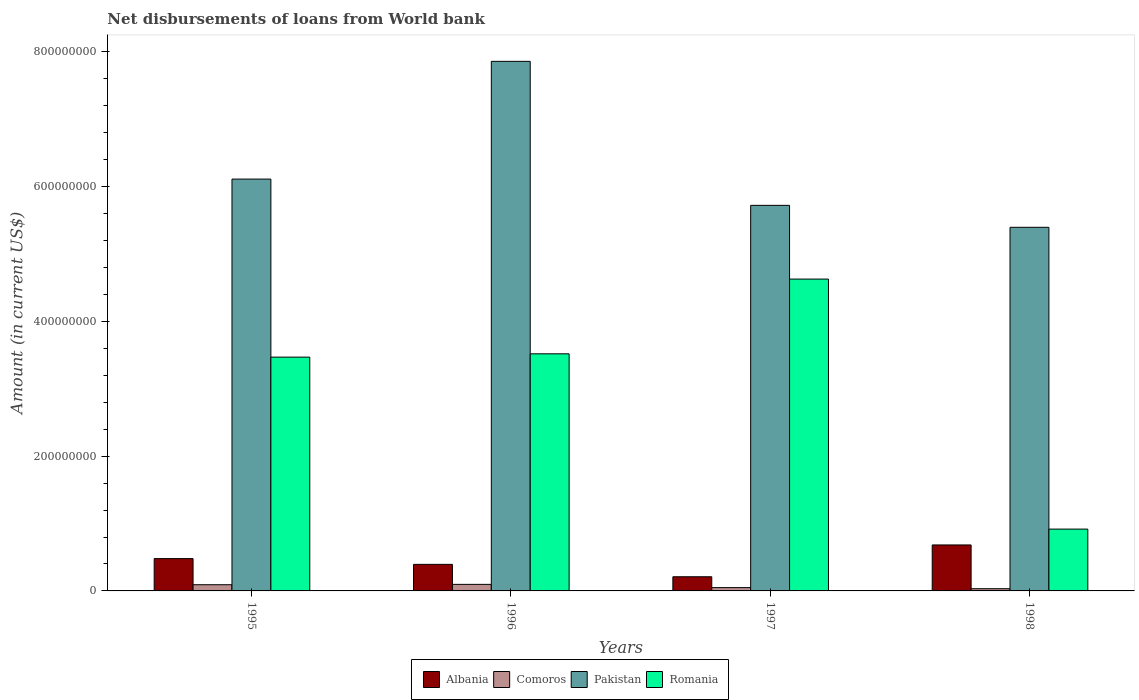How many different coloured bars are there?
Offer a very short reply. 4. How many groups of bars are there?
Your response must be concise. 4. Are the number of bars on each tick of the X-axis equal?
Make the answer very short. Yes. How many bars are there on the 4th tick from the left?
Ensure brevity in your answer.  4. How many bars are there on the 4th tick from the right?
Provide a succinct answer. 4. What is the label of the 2nd group of bars from the left?
Give a very brief answer. 1996. What is the amount of loan disbursed from World Bank in Pakistan in 1996?
Your answer should be very brief. 7.86e+08. Across all years, what is the maximum amount of loan disbursed from World Bank in Comoros?
Provide a short and direct response. 9.73e+06. Across all years, what is the minimum amount of loan disbursed from World Bank in Albania?
Provide a succinct answer. 2.10e+07. What is the total amount of loan disbursed from World Bank in Pakistan in the graph?
Give a very brief answer. 2.51e+09. What is the difference between the amount of loan disbursed from World Bank in Albania in 1995 and that in 1997?
Give a very brief answer. 2.70e+07. What is the difference between the amount of loan disbursed from World Bank in Romania in 1997 and the amount of loan disbursed from World Bank in Albania in 1995?
Provide a short and direct response. 4.15e+08. What is the average amount of loan disbursed from World Bank in Comoros per year?
Ensure brevity in your answer.  6.78e+06. In the year 1998, what is the difference between the amount of loan disbursed from World Bank in Albania and amount of loan disbursed from World Bank in Romania?
Give a very brief answer. -2.35e+07. What is the ratio of the amount of loan disbursed from World Bank in Albania in 1995 to that in 1996?
Your answer should be very brief. 1.22. What is the difference between the highest and the second highest amount of loan disbursed from World Bank in Pakistan?
Your answer should be compact. 1.75e+08. What is the difference between the highest and the lowest amount of loan disbursed from World Bank in Romania?
Your answer should be very brief. 3.71e+08. What does the 1st bar from the left in 1997 represents?
Offer a very short reply. Albania. What does the 3rd bar from the right in 1997 represents?
Your response must be concise. Comoros. Is it the case that in every year, the sum of the amount of loan disbursed from World Bank in Albania and amount of loan disbursed from World Bank in Pakistan is greater than the amount of loan disbursed from World Bank in Romania?
Provide a short and direct response. Yes. Are all the bars in the graph horizontal?
Your answer should be very brief. No. How many years are there in the graph?
Offer a very short reply. 4. Are the values on the major ticks of Y-axis written in scientific E-notation?
Provide a succinct answer. No. Does the graph contain grids?
Provide a succinct answer. No. What is the title of the graph?
Provide a succinct answer. Net disbursements of loans from World bank. What is the label or title of the Y-axis?
Provide a short and direct response. Amount (in current US$). What is the Amount (in current US$) of Albania in 1995?
Give a very brief answer. 4.80e+07. What is the Amount (in current US$) in Comoros in 1995?
Provide a succinct answer. 9.19e+06. What is the Amount (in current US$) in Pakistan in 1995?
Your answer should be compact. 6.11e+08. What is the Amount (in current US$) in Romania in 1995?
Offer a very short reply. 3.47e+08. What is the Amount (in current US$) of Albania in 1996?
Your response must be concise. 3.94e+07. What is the Amount (in current US$) of Comoros in 1996?
Keep it short and to the point. 9.73e+06. What is the Amount (in current US$) in Pakistan in 1996?
Ensure brevity in your answer.  7.86e+08. What is the Amount (in current US$) in Romania in 1996?
Your answer should be compact. 3.52e+08. What is the Amount (in current US$) in Albania in 1997?
Give a very brief answer. 2.10e+07. What is the Amount (in current US$) of Comoros in 1997?
Your response must be concise. 4.89e+06. What is the Amount (in current US$) of Pakistan in 1997?
Offer a terse response. 5.72e+08. What is the Amount (in current US$) in Romania in 1997?
Offer a terse response. 4.63e+08. What is the Amount (in current US$) of Albania in 1998?
Provide a short and direct response. 6.82e+07. What is the Amount (in current US$) in Comoros in 1998?
Offer a terse response. 3.28e+06. What is the Amount (in current US$) in Pakistan in 1998?
Provide a short and direct response. 5.40e+08. What is the Amount (in current US$) of Romania in 1998?
Your answer should be compact. 9.17e+07. Across all years, what is the maximum Amount (in current US$) of Albania?
Your answer should be very brief. 6.82e+07. Across all years, what is the maximum Amount (in current US$) of Comoros?
Your answer should be compact. 9.73e+06. Across all years, what is the maximum Amount (in current US$) of Pakistan?
Your response must be concise. 7.86e+08. Across all years, what is the maximum Amount (in current US$) of Romania?
Give a very brief answer. 4.63e+08. Across all years, what is the minimum Amount (in current US$) in Albania?
Your answer should be very brief. 2.10e+07. Across all years, what is the minimum Amount (in current US$) in Comoros?
Your answer should be compact. 3.28e+06. Across all years, what is the minimum Amount (in current US$) in Pakistan?
Offer a very short reply. 5.40e+08. Across all years, what is the minimum Amount (in current US$) in Romania?
Your answer should be very brief. 9.17e+07. What is the total Amount (in current US$) in Albania in the graph?
Your answer should be very brief. 1.77e+08. What is the total Amount (in current US$) of Comoros in the graph?
Offer a terse response. 2.71e+07. What is the total Amount (in current US$) of Pakistan in the graph?
Ensure brevity in your answer.  2.51e+09. What is the total Amount (in current US$) in Romania in the graph?
Ensure brevity in your answer.  1.25e+09. What is the difference between the Amount (in current US$) of Albania in 1995 and that in 1996?
Your answer should be very brief. 8.56e+06. What is the difference between the Amount (in current US$) in Comoros in 1995 and that in 1996?
Ensure brevity in your answer.  -5.46e+05. What is the difference between the Amount (in current US$) of Pakistan in 1995 and that in 1996?
Provide a succinct answer. -1.75e+08. What is the difference between the Amount (in current US$) in Romania in 1995 and that in 1996?
Keep it short and to the point. -4.93e+06. What is the difference between the Amount (in current US$) in Albania in 1995 and that in 1997?
Ensure brevity in your answer.  2.70e+07. What is the difference between the Amount (in current US$) in Comoros in 1995 and that in 1997?
Your answer should be very brief. 4.30e+06. What is the difference between the Amount (in current US$) in Pakistan in 1995 and that in 1997?
Provide a succinct answer. 3.90e+07. What is the difference between the Amount (in current US$) in Romania in 1995 and that in 1997?
Give a very brief answer. -1.16e+08. What is the difference between the Amount (in current US$) in Albania in 1995 and that in 1998?
Provide a short and direct response. -2.03e+07. What is the difference between the Amount (in current US$) in Comoros in 1995 and that in 1998?
Offer a terse response. 5.90e+06. What is the difference between the Amount (in current US$) in Pakistan in 1995 and that in 1998?
Your answer should be very brief. 7.16e+07. What is the difference between the Amount (in current US$) of Romania in 1995 and that in 1998?
Offer a terse response. 2.55e+08. What is the difference between the Amount (in current US$) of Albania in 1996 and that in 1997?
Your answer should be compact. 1.84e+07. What is the difference between the Amount (in current US$) in Comoros in 1996 and that in 1997?
Your response must be concise. 4.84e+06. What is the difference between the Amount (in current US$) of Pakistan in 1996 and that in 1997?
Your answer should be compact. 2.14e+08. What is the difference between the Amount (in current US$) in Romania in 1996 and that in 1997?
Your answer should be compact. -1.11e+08. What is the difference between the Amount (in current US$) of Albania in 1996 and that in 1998?
Your response must be concise. -2.88e+07. What is the difference between the Amount (in current US$) of Comoros in 1996 and that in 1998?
Keep it short and to the point. 6.45e+06. What is the difference between the Amount (in current US$) in Pakistan in 1996 and that in 1998?
Make the answer very short. 2.46e+08. What is the difference between the Amount (in current US$) in Romania in 1996 and that in 1998?
Provide a succinct answer. 2.60e+08. What is the difference between the Amount (in current US$) in Albania in 1997 and that in 1998?
Provide a short and direct response. -4.72e+07. What is the difference between the Amount (in current US$) of Comoros in 1997 and that in 1998?
Provide a short and direct response. 1.61e+06. What is the difference between the Amount (in current US$) of Pakistan in 1997 and that in 1998?
Offer a very short reply. 3.26e+07. What is the difference between the Amount (in current US$) of Romania in 1997 and that in 1998?
Your response must be concise. 3.71e+08. What is the difference between the Amount (in current US$) in Albania in 1995 and the Amount (in current US$) in Comoros in 1996?
Keep it short and to the point. 3.82e+07. What is the difference between the Amount (in current US$) of Albania in 1995 and the Amount (in current US$) of Pakistan in 1996?
Offer a terse response. -7.38e+08. What is the difference between the Amount (in current US$) in Albania in 1995 and the Amount (in current US$) in Romania in 1996?
Your answer should be very brief. -3.04e+08. What is the difference between the Amount (in current US$) in Comoros in 1995 and the Amount (in current US$) in Pakistan in 1996?
Your answer should be compact. -7.77e+08. What is the difference between the Amount (in current US$) in Comoros in 1995 and the Amount (in current US$) in Romania in 1996?
Ensure brevity in your answer.  -3.43e+08. What is the difference between the Amount (in current US$) in Pakistan in 1995 and the Amount (in current US$) in Romania in 1996?
Ensure brevity in your answer.  2.59e+08. What is the difference between the Amount (in current US$) in Albania in 1995 and the Amount (in current US$) in Comoros in 1997?
Your answer should be compact. 4.31e+07. What is the difference between the Amount (in current US$) of Albania in 1995 and the Amount (in current US$) of Pakistan in 1997?
Offer a very short reply. -5.24e+08. What is the difference between the Amount (in current US$) of Albania in 1995 and the Amount (in current US$) of Romania in 1997?
Make the answer very short. -4.15e+08. What is the difference between the Amount (in current US$) in Comoros in 1995 and the Amount (in current US$) in Pakistan in 1997?
Give a very brief answer. -5.63e+08. What is the difference between the Amount (in current US$) of Comoros in 1995 and the Amount (in current US$) of Romania in 1997?
Keep it short and to the point. -4.54e+08. What is the difference between the Amount (in current US$) of Pakistan in 1995 and the Amount (in current US$) of Romania in 1997?
Your response must be concise. 1.48e+08. What is the difference between the Amount (in current US$) of Albania in 1995 and the Amount (in current US$) of Comoros in 1998?
Your response must be concise. 4.47e+07. What is the difference between the Amount (in current US$) in Albania in 1995 and the Amount (in current US$) in Pakistan in 1998?
Keep it short and to the point. -4.92e+08. What is the difference between the Amount (in current US$) in Albania in 1995 and the Amount (in current US$) in Romania in 1998?
Keep it short and to the point. -4.38e+07. What is the difference between the Amount (in current US$) of Comoros in 1995 and the Amount (in current US$) of Pakistan in 1998?
Ensure brevity in your answer.  -5.31e+08. What is the difference between the Amount (in current US$) of Comoros in 1995 and the Amount (in current US$) of Romania in 1998?
Your answer should be compact. -8.26e+07. What is the difference between the Amount (in current US$) of Pakistan in 1995 and the Amount (in current US$) of Romania in 1998?
Your answer should be very brief. 5.20e+08. What is the difference between the Amount (in current US$) in Albania in 1996 and the Amount (in current US$) in Comoros in 1997?
Provide a succinct answer. 3.45e+07. What is the difference between the Amount (in current US$) in Albania in 1996 and the Amount (in current US$) in Pakistan in 1997?
Give a very brief answer. -5.33e+08. What is the difference between the Amount (in current US$) of Albania in 1996 and the Amount (in current US$) of Romania in 1997?
Provide a short and direct response. -4.23e+08. What is the difference between the Amount (in current US$) of Comoros in 1996 and the Amount (in current US$) of Pakistan in 1997?
Provide a short and direct response. -5.63e+08. What is the difference between the Amount (in current US$) of Comoros in 1996 and the Amount (in current US$) of Romania in 1997?
Ensure brevity in your answer.  -4.53e+08. What is the difference between the Amount (in current US$) in Pakistan in 1996 and the Amount (in current US$) in Romania in 1997?
Offer a very short reply. 3.23e+08. What is the difference between the Amount (in current US$) in Albania in 1996 and the Amount (in current US$) in Comoros in 1998?
Offer a very short reply. 3.61e+07. What is the difference between the Amount (in current US$) in Albania in 1996 and the Amount (in current US$) in Pakistan in 1998?
Give a very brief answer. -5.00e+08. What is the difference between the Amount (in current US$) of Albania in 1996 and the Amount (in current US$) of Romania in 1998?
Make the answer very short. -5.23e+07. What is the difference between the Amount (in current US$) of Comoros in 1996 and the Amount (in current US$) of Pakistan in 1998?
Offer a very short reply. -5.30e+08. What is the difference between the Amount (in current US$) of Comoros in 1996 and the Amount (in current US$) of Romania in 1998?
Provide a succinct answer. -8.20e+07. What is the difference between the Amount (in current US$) in Pakistan in 1996 and the Amount (in current US$) in Romania in 1998?
Make the answer very short. 6.94e+08. What is the difference between the Amount (in current US$) of Albania in 1997 and the Amount (in current US$) of Comoros in 1998?
Your answer should be compact. 1.77e+07. What is the difference between the Amount (in current US$) in Albania in 1997 and the Amount (in current US$) in Pakistan in 1998?
Offer a very short reply. -5.19e+08. What is the difference between the Amount (in current US$) in Albania in 1997 and the Amount (in current US$) in Romania in 1998?
Offer a very short reply. -7.07e+07. What is the difference between the Amount (in current US$) in Comoros in 1997 and the Amount (in current US$) in Pakistan in 1998?
Keep it short and to the point. -5.35e+08. What is the difference between the Amount (in current US$) in Comoros in 1997 and the Amount (in current US$) in Romania in 1998?
Your answer should be compact. -8.69e+07. What is the difference between the Amount (in current US$) in Pakistan in 1997 and the Amount (in current US$) in Romania in 1998?
Offer a very short reply. 4.81e+08. What is the average Amount (in current US$) in Albania per year?
Give a very brief answer. 4.42e+07. What is the average Amount (in current US$) in Comoros per year?
Give a very brief answer. 6.78e+06. What is the average Amount (in current US$) in Pakistan per year?
Provide a short and direct response. 6.27e+08. What is the average Amount (in current US$) in Romania per year?
Your response must be concise. 3.13e+08. In the year 1995, what is the difference between the Amount (in current US$) in Albania and Amount (in current US$) in Comoros?
Make the answer very short. 3.88e+07. In the year 1995, what is the difference between the Amount (in current US$) of Albania and Amount (in current US$) of Pakistan?
Offer a very short reply. -5.63e+08. In the year 1995, what is the difference between the Amount (in current US$) of Albania and Amount (in current US$) of Romania?
Your answer should be very brief. -2.99e+08. In the year 1995, what is the difference between the Amount (in current US$) of Comoros and Amount (in current US$) of Pakistan?
Your response must be concise. -6.02e+08. In the year 1995, what is the difference between the Amount (in current US$) in Comoros and Amount (in current US$) in Romania?
Provide a short and direct response. -3.38e+08. In the year 1995, what is the difference between the Amount (in current US$) in Pakistan and Amount (in current US$) in Romania?
Ensure brevity in your answer.  2.64e+08. In the year 1996, what is the difference between the Amount (in current US$) of Albania and Amount (in current US$) of Comoros?
Your answer should be very brief. 2.97e+07. In the year 1996, what is the difference between the Amount (in current US$) of Albania and Amount (in current US$) of Pakistan?
Offer a terse response. -7.47e+08. In the year 1996, what is the difference between the Amount (in current US$) of Albania and Amount (in current US$) of Romania?
Your answer should be very brief. -3.13e+08. In the year 1996, what is the difference between the Amount (in current US$) in Comoros and Amount (in current US$) in Pakistan?
Offer a terse response. -7.76e+08. In the year 1996, what is the difference between the Amount (in current US$) of Comoros and Amount (in current US$) of Romania?
Offer a terse response. -3.42e+08. In the year 1996, what is the difference between the Amount (in current US$) in Pakistan and Amount (in current US$) in Romania?
Your answer should be compact. 4.34e+08. In the year 1997, what is the difference between the Amount (in current US$) of Albania and Amount (in current US$) of Comoros?
Provide a short and direct response. 1.61e+07. In the year 1997, what is the difference between the Amount (in current US$) in Albania and Amount (in current US$) in Pakistan?
Provide a short and direct response. -5.51e+08. In the year 1997, what is the difference between the Amount (in current US$) in Albania and Amount (in current US$) in Romania?
Give a very brief answer. -4.42e+08. In the year 1997, what is the difference between the Amount (in current US$) in Comoros and Amount (in current US$) in Pakistan?
Your answer should be very brief. -5.67e+08. In the year 1997, what is the difference between the Amount (in current US$) in Comoros and Amount (in current US$) in Romania?
Provide a short and direct response. -4.58e+08. In the year 1997, what is the difference between the Amount (in current US$) of Pakistan and Amount (in current US$) of Romania?
Provide a short and direct response. 1.09e+08. In the year 1998, what is the difference between the Amount (in current US$) in Albania and Amount (in current US$) in Comoros?
Your response must be concise. 6.49e+07. In the year 1998, what is the difference between the Amount (in current US$) in Albania and Amount (in current US$) in Pakistan?
Keep it short and to the point. -4.71e+08. In the year 1998, what is the difference between the Amount (in current US$) of Albania and Amount (in current US$) of Romania?
Give a very brief answer. -2.35e+07. In the year 1998, what is the difference between the Amount (in current US$) of Comoros and Amount (in current US$) of Pakistan?
Give a very brief answer. -5.36e+08. In the year 1998, what is the difference between the Amount (in current US$) in Comoros and Amount (in current US$) in Romania?
Provide a succinct answer. -8.85e+07. In the year 1998, what is the difference between the Amount (in current US$) of Pakistan and Amount (in current US$) of Romania?
Offer a very short reply. 4.48e+08. What is the ratio of the Amount (in current US$) in Albania in 1995 to that in 1996?
Make the answer very short. 1.22. What is the ratio of the Amount (in current US$) of Comoros in 1995 to that in 1996?
Provide a succinct answer. 0.94. What is the ratio of the Amount (in current US$) in Pakistan in 1995 to that in 1996?
Your answer should be very brief. 0.78. What is the ratio of the Amount (in current US$) in Romania in 1995 to that in 1996?
Offer a terse response. 0.99. What is the ratio of the Amount (in current US$) of Albania in 1995 to that in 1997?
Offer a terse response. 2.28. What is the ratio of the Amount (in current US$) of Comoros in 1995 to that in 1997?
Ensure brevity in your answer.  1.88. What is the ratio of the Amount (in current US$) in Pakistan in 1995 to that in 1997?
Your response must be concise. 1.07. What is the ratio of the Amount (in current US$) of Romania in 1995 to that in 1997?
Keep it short and to the point. 0.75. What is the ratio of the Amount (in current US$) of Albania in 1995 to that in 1998?
Your answer should be compact. 0.7. What is the ratio of the Amount (in current US$) of Comoros in 1995 to that in 1998?
Provide a succinct answer. 2.8. What is the ratio of the Amount (in current US$) in Pakistan in 1995 to that in 1998?
Your answer should be compact. 1.13. What is the ratio of the Amount (in current US$) of Romania in 1995 to that in 1998?
Keep it short and to the point. 3.78. What is the ratio of the Amount (in current US$) in Albania in 1996 to that in 1997?
Provide a succinct answer. 1.88. What is the ratio of the Amount (in current US$) in Comoros in 1996 to that in 1997?
Keep it short and to the point. 1.99. What is the ratio of the Amount (in current US$) of Pakistan in 1996 to that in 1997?
Your response must be concise. 1.37. What is the ratio of the Amount (in current US$) in Romania in 1996 to that in 1997?
Ensure brevity in your answer.  0.76. What is the ratio of the Amount (in current US$) in Albania in 1996 to that in 1998?
Provide a short and direct response. 0.58. What is the ratio of the Amount (in current US$) in Comoros in 1996 to that in 1998?
Offer a terse response. 2.96. What is the ratio of the Amount (in current US$) of Pakistan in 1996 to that in 1998?
Offer a very short reply. 1.46. What is the ratio of the Amount (in current US$) in Romania in 1996 to that in 1998?
Provide a succinct answer. 3.84. What is the ratio of the Amount (in current US$) of Albania in 1997 to that in 1998?
Offer a terse response. 0.31. What is the ratio of the Amount (in current US$) in Comoros in 1997 to that in 1998?
Keep it short and to the point. 1.49. What is the ratio of the Amount (in current US$) of Pakistan in 1997 to that in 1998?
Your answer should be very brief. 1.06. What is the ratio of the Amount (in current US$) of Romania in 1997 to that in 1998?
Make the answer very short. 5.04. What is the difference between the highest and the second highest Amount (in current US$) in Albania?
Give a very brief answer. 2.03e+07. What is the difference between the highest and the second highest Amount (in current US$) in Comoros?
Offer a terse response. 5.46e+05. What is the difference between the highest and the second highest Amount (in current US$) in Pakistan?
Keep it short and to the point. 1.75e+08. What is the difference between the highest and the second highest Amount (in current US$) of Romania?
Offer a terse response. 1.11e+08. What is the difference between the highest and the lowest Amount (in current US$) of Albania?
Offer a very short reply. 4.72e+07. What is the difference between the highest and the lowest Amount (in current US$) in Comoros?
Your answer should be compact. 6.45e+06. What is the difference between the highest and the lowest Amount (in current US$) of Pakistan?
Your answer should be compact. 2.46e+08. What is the difference between the highest and the lowest Amount (in current US$) in Romania?
Offer a terse response. 3.71e+08. 